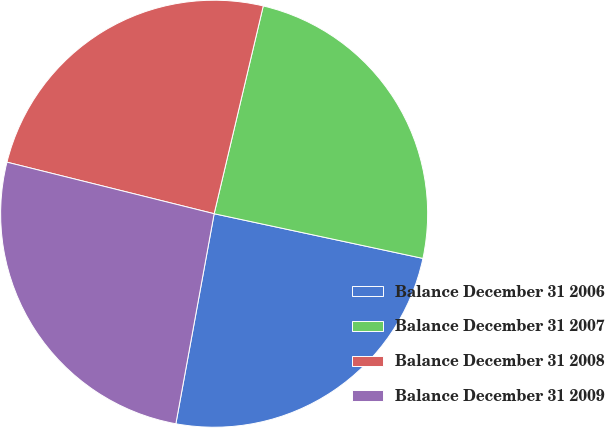Convert chart. <chart><loc_0><loc_0><loc_500><loc_500><pie_chart><fcel>Balance December 31 2006<fcel>Balance December 31 2007<fcel>Balance December 31 2008<fcel>Balance December 31 2009<nl><fcel>24.51%<fcel>24.66%<fcel>24.81%<fcel>26.01%<nl></chart> 